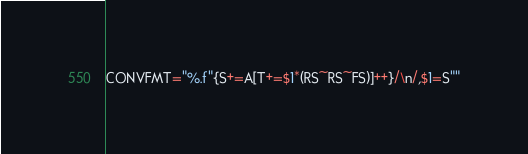<code> <loc_0><loc_0><loc_500><loc_500><_Awk_>CONVFMT="%.f"{S+=A[T+=$1*(RS~RS~FS)]++}/\n/,$1=S""</code> 